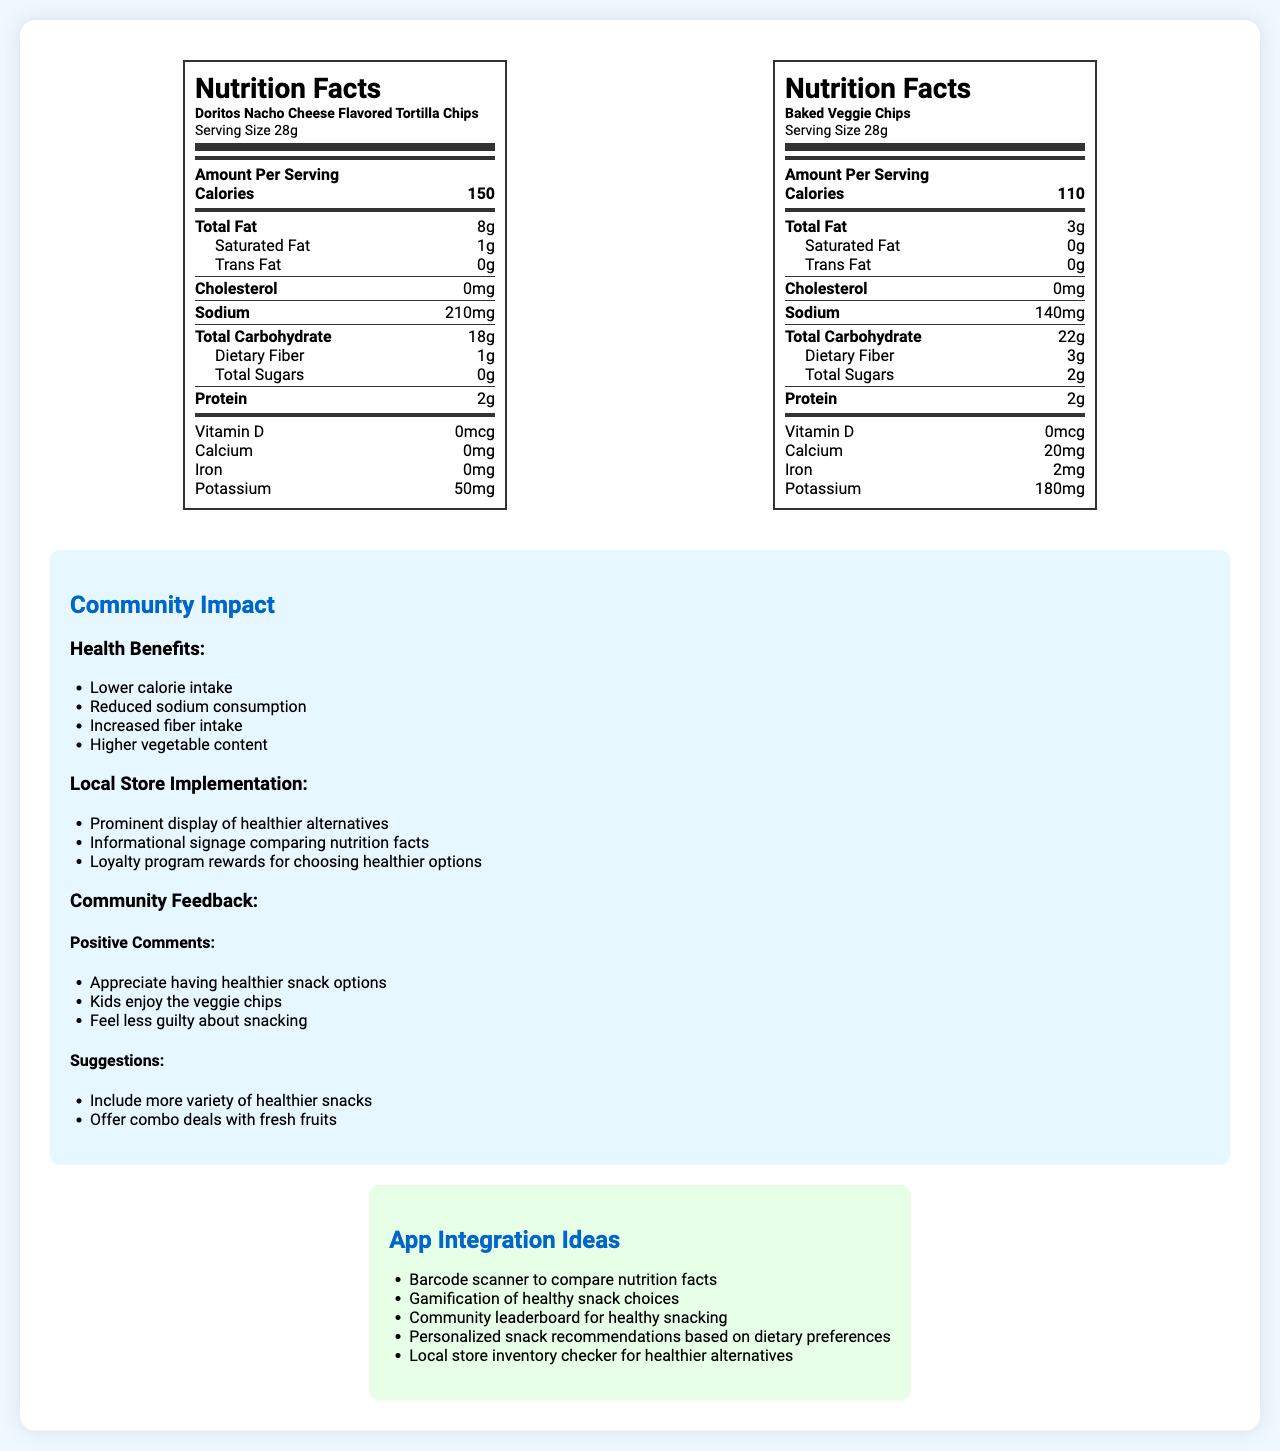What is the serving size for Doritos Nacho Cheese Flavored Tortilla Chips? The serving size for Doritos Nacho Cheese Flavored Tortilla Chips is mentioned at the top of the nutrition label for that snack.
Answer: 28g How many calories are in a serving of Baked Veggie Chips? The number of calories per serving for Baked Veggie Chips is listed right under the label header in the "Amount Per Serving" section.
Answer: 110 Which snack contains more dietary fiber per serving? The Baked Veggie Chips contain 3g of dietary fiber per serving compared to 1g in Doritos Nacho Cheese Flavored Tortilla Chips.
Answer: Baked Veggie Chips Does the Baked Veggie Chips have any cholesterol? The nutrition label indicates that Baked Veggie Chips contain 0mg of cholesterol.
Answer: No Name three health benefits of choosing the healthier alternative over the original snack. The health benefits listed in the Community Impact section include lower calorie intake, reduced sodium consumption, and increased fiber intake.
Answer: Lower calorie intake, Reduced sodium consumption, Increased fiber intake Which snack has more sodium per serving? 
A. Doritos Nacho Cheese Flavored Tortilla Chips 
B. Baked Veggie Chips Doritos Nacho Cheese Flavored Tortilla Chips have 210mg of sodium per serving, whereas Baked Veggie Chips have 140mg.
Answer: A. Doritos Nacho Cheese Flavored Tortilla Chips Which option contains more sugar?
I. Doritos Nacho Cheese Flavored Tortilla Chips
II. Baked Veggie Chips Baked Veggie Chips contain 2g of total sugars, whereas Doritos Nacho Cheese Flavored Tortilla Chips have 0g.
Answer: II. Baked Veggie Chips Are there any implementation ideas for local stores to promote healthier alternatives? The Local Store Implementation section lists several ideas such as prominent display of healthier alternatives and informational signage comparing nutrition facts.
Answer: Yes Summarize the main idea of the document. The document compares the nutrition facts of Doritos Nacho Cheese Flavored Tortilla Chips with Baked Veggie Chips, highlighting the health benefits of the latter, along with suggestions for store implementation and community feedback.
Answer: A comparative nutrition facts label showcases healthier alternatives to popular snacks, with additional information on community health benefits, store implementation ideas, community feedback, and app integration suggestions. What is the specific Vitamin D content in Doritos? The Vitamin D content for Doritos Nacho Cheese Flavored Tortilla Chips is listed as 0 mcg in the nutrition label.
Answer: 0 mcg What suggestions did the community provide for improvements? The suggestions section under Community Feedback lists these two specific suggestions.
Answer: Include more variety of healthier snacks and offer combo deals with fresh fruits How many app integration ideas are mentioned in the document? There are five app integration ideas mentioned, including a barcode scanner to compare nutrition facts and gamification of healthy snack choices.
Answer: Five What are the long-term benefits of choosing healthier snacks according to the document? These benefits are listed in the Educational Content section under long-term benefits.
Answer: Reduced risk of obesity, Better heart health, Improved digestion Is there information on how these snacks impact mental health? There is no specific mention of mental health impacts in the provided sections of the document.
Answer: Not enough information 